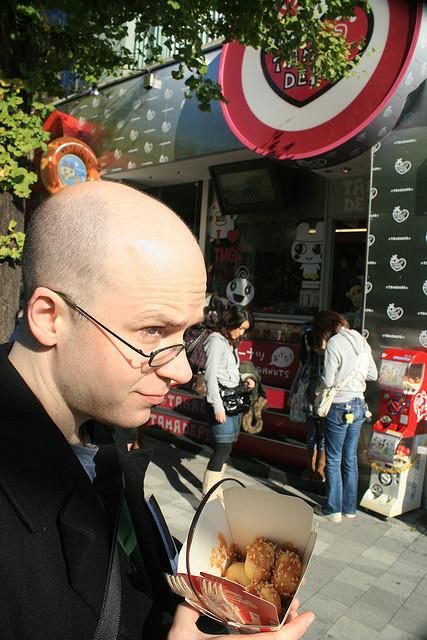Is the man looking at the camera?
Concise answer only. No. What is the man eating?
Give a very brief answer. Pretzels. What is he eating?
Quick response, please. Pretzels. 